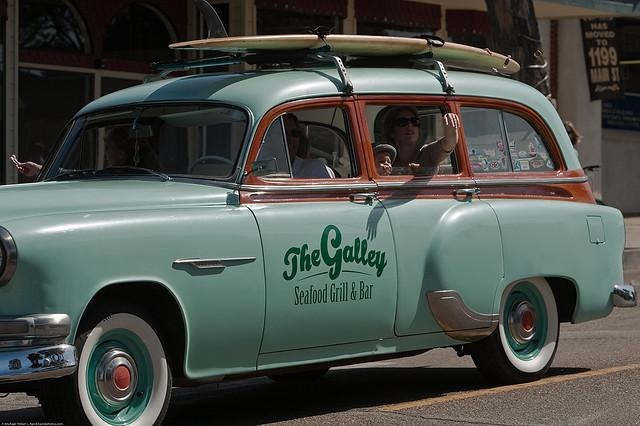Which one of these natural disasters might this car get caught in? tsunami 